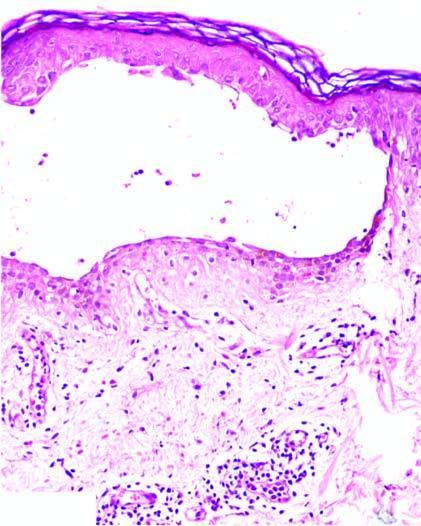s an intraepidermal bulla in suprabasal location containing acantholytic cells seen?
Answer the question using a single word or phrase. Yes 